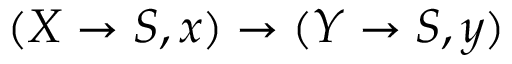Convert formula to latex. <formula><loc_0><loc_0><loc_500><loc_500>( X \to S , x ) \to ( Y \to S , y )</formula> 